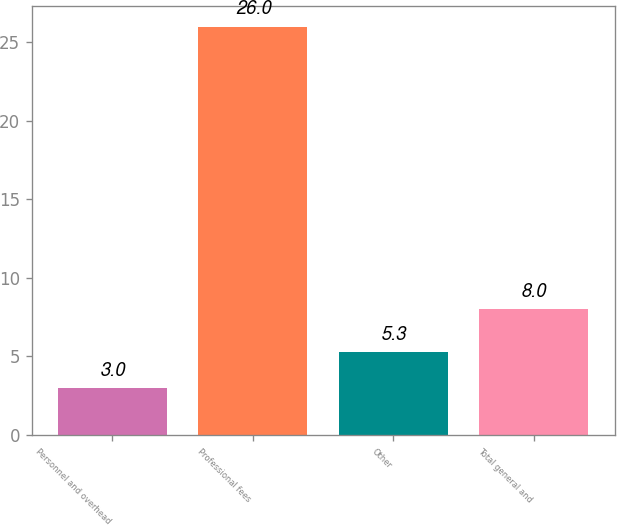<chart> <loc_0><loc_0><loc_500><loc_500><bar_chart><fcel>Personnel and overhead<fcel>Professional fees<fcel>Other<fcel>Total general and<nl><fcel>3<fcel>26<fcel>5.3<fcel>8<nl></chart> 